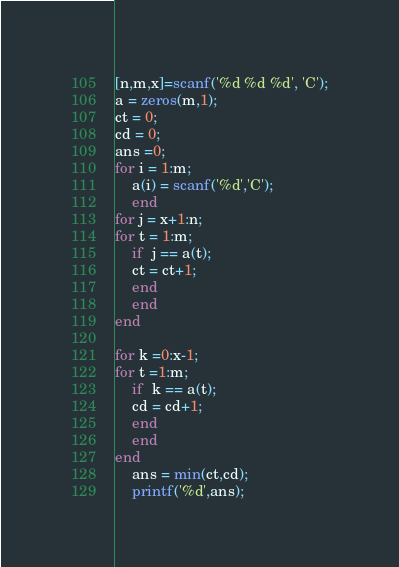<code> <loc_0><loc_0><loc_500><loc_500><_Octave_>[n,m,x]=scanf('%d %d %d', 'C');
a = zeros(m,1);
ct = 0;
cd = 0;
ans =0;
for i = 1:m;
	a(i) = scanf('%d','C'); 
    end
for j = x+1:n;
for t = 1:m;
    if  j == a(t);
    ct = ct+1;
    end
    end  
end

for k =0:x-1;
for t =1:m;
    if  k == a(t);
    cd = cd+1;
    end
    end
end
    ans = min(ct,cd);
    printf('%d',ans);</code> 